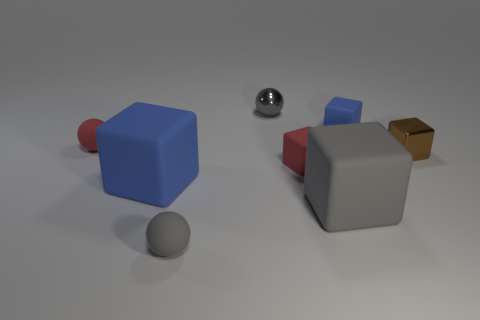How many gray balls must be subtracted to get 1 gray balls? 1 Subtract all small blue matte cubes. How many cubes are left? 4 Subtract 1 cubes. How many cubes are left? 4 Subtract all blue blocks. How many blocks are left? 3 Add 1 yellow blocks. How many objects exist? 9 Subtract all purple cubes. Subtract all yellow balls. How many cubes are left? 5 Subtract all cubes. How many objects are left? 3 Subtract 0 cyan spheres. How many objects are left? 8 Subtract all blue matte blocks. Subtract all small metal balls. How many objects are left? 5 Add 3 big things. How many big things are left? 5 